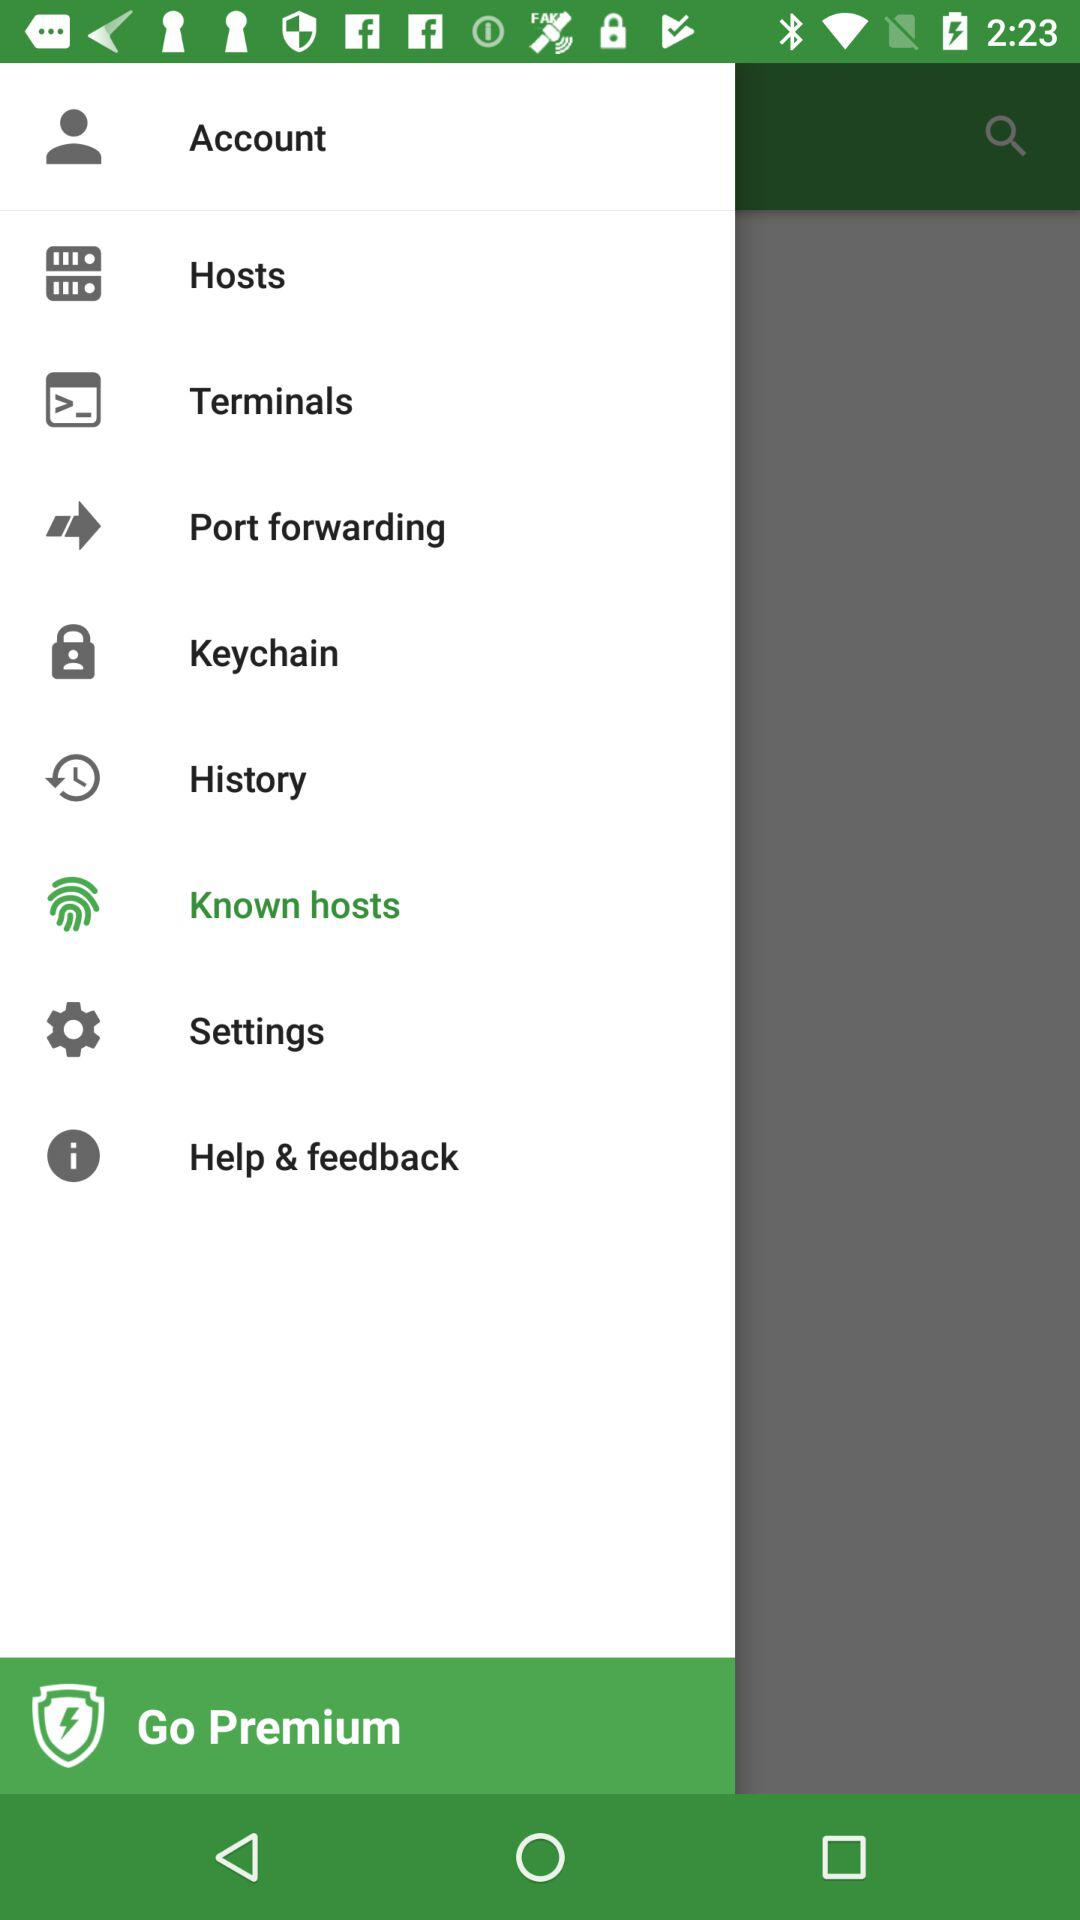Which item is selected? The selected item is "Known hosts". 